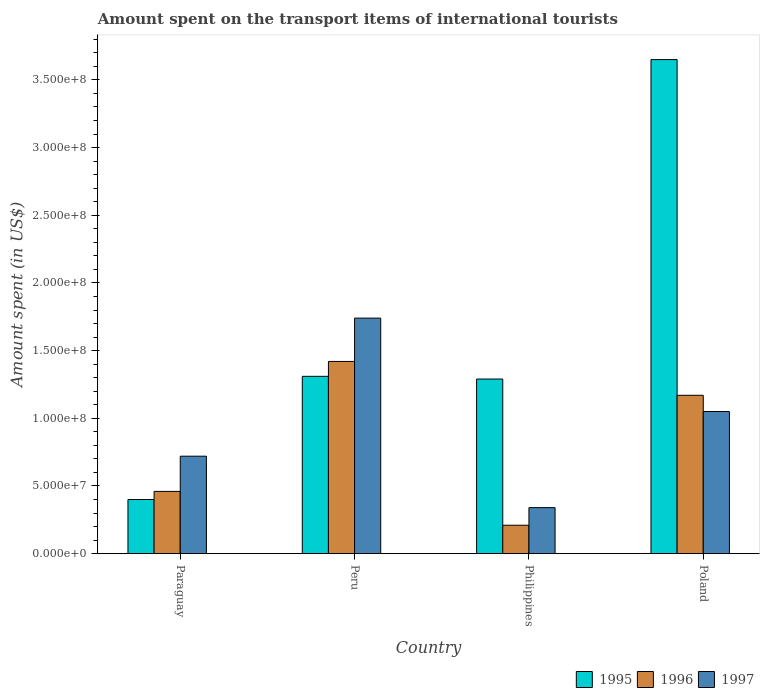How many groups of bars are there?
Offer a terse response. 4. Are the number of bars per tick equal to the number of legend labels?
Offer a terse response. Yes. Are the number of bars on each tick of the X-axis equal?
Your answer should be very brief. Yes. How many bars are there on the 1st tick from the left?
Provide a succinct answer. 3. How many bars are there on the 4th tick from the right?
Your answer should be compact. 3. What is the amount spent on the transport items of international tourists in 1995 in Poland?
Give a very brief answer. 3.65e+08. Across all countries, what is the maximum amount spent on the transport items of international tourists in 1997?
Offer a very short reply. 1.74e+08. Across all countries, what is the minimum amount spent on the transport items of international tourists in 1995?
Make the answer very short. 4.00e+07. What is the total amount spent on the transport items of international tourists in 1996 in the graph?
Ensure brevity in your answer.  3.26e+08. What is the difference between the amount spent on the transport items of international tourists in 1995 in Peru and that in Poland?
Give a very brief answer. -2.34e+08. What is the difference between the amount spent on the transport items of international tourists in 1997 in Poland and the amount spent on the transport items of international tourists in 1996 in Paraguay?
Make the answer very short. 5.90e+07. What is the average amount spent on the transport items of international tourists in 1995 per country?
Keep it short and to the point. 1.66e+08. What is the difference between the amount spent on the transport items of international tourists of/in 1997 and amount spent on the transport items of international tourists of/in 1995 in Poland?
Ensure brevity in your answer.  -2.60e+08. In how many countries, is the amount spent on the transport items of international tourists in 1996 greater than 50000000 US$?
Keep it short and to the point. 2. What is the ratio of the amount spent on the transport items of international tourists in 1996 in Paraguay to that in Peru?
Ensure brevity in your answer.  0.32. What is the difference between the highest and the second highest amount spent on the transport items of international tourists in 1995?
Your response must be concise. 2.36e+08. What is the difference between the highest and the lowest amount spent on the transport items of international tourists in 1995?
Offer a very short reply. 3.25e+08. In how many countries, is the amount spent on the transport items of international tourists in 1996 greater than the average amount spent on the transport items of international tourists in 1996 taken over all countries?
Ensure brevity in your answer.  2. Is the sum of the amount spent on the transport items of international tourists in 1997 in Paraguay and Philippines greater than the maximum amount spent on the transport items of international tourists in 1996 across all countries?
Provide a succinct answer. No. What does the 3rd bar from the left in Poland represents?
Provide a short and direct response. 1997. What does the 1st bar from the right in Peru represents?
Give a very brief answer. 1997. Is it the case that in every country, the sum of the amount spent on the transport items of international tourists in 1996 and amount spent on the transport items of international tourists in 1997 is greater than the amount spent on the transport items of international tourists in 1995?
Offer a very short reply. No. Are all the bars in the graph horizontal?
Make the answer very short. No. How many countries are there in the graph?
Your answer should be very brief. 4. What is the difference between two consecutive major ticks on the Y-axis?
Offer a very short reply. 5.00e+07. Does the graph contain any zero values?
Provide a succinct answer. No. Where does the legend appear in the graph?
Offer a terse response. Bottom right. How many legend labels are there?
Ensure brevity in your answer.  3. How are the legend labels stacked?
Ensure brevity in your answer.  Horizontal. What is the title of the graph?
Make the answer very short. Amount spent on the transport items of international tourists. Does "2012" appear as one of the legend labels in the graph?
Your response must be concise. No. What is the label or title of the X-axis?
Your response must be concise. Country. What is the label or title of the Y-axis?
Make the answer very short. Amount spent (in US$). What is the Amount spent (in US$) in 1995 in Paraguay?
Give a very brief answer. 4.00e+07. What is the Amount spent (in US$) in 1996 in Paraguay?
Your answer should be very brief. 4.60e+07. What is the Amount spent (in US$) in 1997 in Paraguay?
Provide a short and direct response. 7.20e+07. What is the Amount spent (in US$) in 1995 in Peru?
Provide a short and direct response. 1.31e+08. What is the Amount spent (in US$) in 1996 in Peru?
Your answer should be compact. 1.42e+08. What is the Amount spent (in US$) of 1997 in Peru?
Provide a short and direct response. 1.74e+08. What is the Amount spent (in US$) in 1995 in Philippines?
Your answer should be very brief. 1.29e+08. What is the Amount spent (in US$) of 1996 in Philippines?
Make the answer very short. 2.10e+07. What is the Amount spent (in US$) in 1997 in Philippines?
Ensure brevity in your answer.  3.40e+07. What is the Amount spent (in US$) of 1995 in Poland?
Offer a very short reply. 3.65e+08. What is the Amount spent (in US$) in 1996 in Poland?
Provide a short and direct response. 1.17e+08. What is the Amount spent (in US$) in 1997 in Poland?
Your response must be concise. 1.05e+08. Across all countries, what is the maximum Amount spent (in US$) in 1995?
Your answer should be very brief. 3.65e+08. Across all countries, what is the maximum Amount spent (in US$) in 1996?
Ensure brevity in your answer.  1.42e+08. Across all countries, what is the maximum Amount spent (in US$) in 1997?
Your response must be concise. 1.74e+08. Across all countries, what is the minimum Amount spent (in US$) in 1995?
Make the answer very short. 4.00e+07. Across all countries, what is the minimum Amount spent (in US$) in 1996?
Your answer should be compact. 2.10e+07. Across all countries, what is the minimum Amount spent (in US$) of 1997?
Provide a short and direct response. 3.40e+07. What is the total Amount spent (in US$) in 1995 in the graph?
Your answer should be compact. 6.65e+08. What is the total Amount spent (in US$) of 1996 in the graph?
Offer a terse response. 3.26e+08. What is the total Amount spent (in US$) of 1997 in the graph?
Provide a succinct answer. 3.85e+08. What is the difference between the Amount spent (in US$) in 1995 in Paraguay and that in Peru?
Provide a succinct answer. -9.10e+07. What is the difference between the Amount spent (in US$) of 1996 in Paraguay and that in Peru?
Keep it short and to the point. -9.60e+07. What is the difference between the Amount spent (in US$) in 1997 in Paraguay and that in Peru?
Your response must be concise. -1.02e+08. What is the difference between the Amount spent (in US$) of 1995 in Paraguay and that in Philippines?
Provide a succinct answer. -8.90e+07. What is the difference between the Amount spent (in US$) in 1996 in Paraguay and that in Philippines?
Offer a terse response. 2.50e+07. What is the difference between the Amount spent (in US$) of 1997 in Paraguay and that in Philippines?
Your answer should be compact. 3.80e+07. What is the difference between the Amount spent (in US$) in 1995 in Paraguay and that in Poland?
Give a very brief answer. -3.25e+08. What is the difference between the Amount spent (in US$) in 1996 in Paraguay and that in Poland?
Your response must be concise. -7.10e+07. What is the difference between the Amount spent (in US$) of 1997 in Paraguay and that in Poland?
Keep it short and to the point. -3.30e+07. What is the difference between the Amount spent (in US$) of 1996 in Peru and that in Philippines?
Offer a terse response. 1.21e+08. What is the difference between the Amount spent (in US$) in 1997 in Peru and that in Philippines?
Offer a terse response. 1.40e+08. What is the difference between the Amount spent (in US$) in 1995 in Peru and that in Poland?
Offer a very short reply. -2.34e+08. What is the difference between the Amount spent (in US$) of 1996 in Peru and that in Poland?
Your answer should be compact. 2.50e+07. What is the difference between the Amount spent (in US$) in 1997 in Peru and that in Poland?
Give a very brief answer. 6.90e+07. What is the difference between the Amount spent (in US$) of 1995 in Philippines and that in Poland?
Ensure brevity in your answer.  -2.36e+08. What is the difference between the Amount spent (in US$) of 1996 in Philippines and that in Poland?
Provide a short and direct response. -9.60e+07. What is the difference between the Amount spent (in US$) in 1997 in Philippines and that in Poland?
Your response must be concise. -7.10e+07. What is the difference between the Amount spent (in US$) in 1995 in Paraguay and the Amount spent (in US$) in 1996 in Peru?
Keep it short and to the point. -1.02e+08. What is the difference between the Amount spent (in US$) of 1995 in Paraguay and the Amount spent (in US$) of 1997 in Peru?
Provide a short and direct response. -1.34e+08. What is the difference between the Amount spent (in US$) in 1996 in Paraguay and the Amount spent (in US$) in 1997 in Peru?
Your response must be concise. -1.28e+08. What is the difference between the Amount spent (in US$) in 1995 in Paraguay and the Amount spent (in US$) in 1996 in Philippines?
Ensure brevity in your answer.  1.90e+07. What is the difference between the Amount spent (in US$) in 1995 in Paraguay and the Amount spent (in US$) in 1997 in Philippines?
Provide a short and direct response. 6.00e+06. What is the difference between the Amount spent (in US$) in 1995 in Paraguay and the Amount spent (in US$) in 1996 in Poland?
Provide a succinct answer. -7.70e+07. What is the difference between the Amount spent (in US$) in 1995 in Paraguay and the Amount spent (in US$) in 1997 in Poland?
Offer a very short reply. -6.50e+07. What is the difference between the Amount spent (in US$) in 1996 in Paraguay and the Amount spent (in US$) in 1997 in Poland?
Make the answer very short. -5.90e+07. What is the difference between the Amount spent (in US$) in 1995 in Peru and the Amount spent (in US$) in 1996 in Philippines?
Ensure brevity in your answer.  1.10e+08. What is the difference between the Amount spent (in US$) in 1995 in Peru and the Amount spent (in US$) in 1997 in Philippines?
Keep it short and to the point. 9.70e+07. What is the difference between the Amount spent (in US$) in 1996 in Peru and the Amount spent (in US$) in 1997 in Philippines?
Your response must be concise. 1.08e+08. What is the difference between the Amount spent (in US$) in 1995 in Peru and the Amount spent (in US$) in 1996 in Poland?
Provide a short and direct response. 1.40e+07. What is the difference between the Amount spent (in US$) of 1995 in Peru and the Amount spent (in US$) of 1997 in Poland?
Offer a very short reply. 2.60e+07. What is the difference between the Amount spent (in US$) of 1996 in Peru and the Amount spent (in US$) of 1997 in Poland?
Your answer should be very brief. 3.70e+07. What is the difference between the Amount spent (in US$) in 1995 in Philippines and the Amount spent (in US$) in 1996 in Poland?
Make the answer very short. 1.20e+07. What is the difference between the Amount spent (in US$) of 1995 in Philippines and the Amount spent (in US$) of 1997 in Poland?
Provide a succinct answer. 2.40e+07. What is the difference between the Amount spent (in US$) in 1996 in Philippines and the Amount spent (in US$) in 1997 in Poland?
Your answer should be very brief. -8.40e+07. What is the average Amount spent (in US$) in 1995 per country?
Ensure brevity in your answer.  1.66e+08. What is the average Amount spent (in US$) of 1996 per country?
Keep it short and to the point. 8.15e+07. What is the average Amount spent (in US$) in 1997 per country?
Provide a succinct answer. 9.62e+07. What is the difference between the Amount spent (in US$) of 1995 and Amount spent (in US$) of 1996 in Paraguay?
Keep it short and to the point. -6.00e+06. What is the difference between the Amount spent (in US$) in 1995 and Amount spent (in US$) in 1997 in Paraguay?
Give a very brief answer. -3.20e+07. What is the difference between the Amount spent (in US$) in 1996 and Amount spent (in US$) in 1997 in Paraguay?
Provide a succinct answer. -2.60e+07. What is the difference between the Amount spent (in US$) of 1995 and Amount spent (in US$) of 1996 in Peru?
Offer a very short reply. -1.10e+07. What is the difference between the Amount spent (in US$) of 1995 and Amount spent (in US$) of 1997 in Peru?
Keep it short and to the point. -4.30e+07. What is the difference between the Amount spent (in US$) in 1996 and Amount spent (in US$) in 1997 in Peru?
Your answer should be compact. -3.20e+07. What is the difference between the Amount spent (in US$) in 1995 and Amount spent (in US$) in 1996 in Philippines?
Offer a terse response. 1.08e+08. What is the difference between the Amount spent (in US$) of 1995 and Amount spent (in US$) of 1997 in Philippines?
Provide a succinct answer. 9.50e+07. What is the difference between the Amount spent (in US$) of 1996 and Amount spent (in US$) of 1997 in Philippines?
Provide a succinct answer. -1.30e+07. What is the difference between the Amount spent (in US$) of 1995 and Amount spent (in US$) of 1996 in Poland?
Provide a succinct answer. 2.48e+08. What is the difference between the Amount spent (in US$) of 1995 and Amount spent (in US$) of 1997 in Poland?
Keep it short and to the point. 2.60e+08. What is the ratio of the Amount spent (in US$) in 1995 in Paraguay to that in Peru?
Ensure brevity in your answer.  0.31. What is the ratio of the Amount spent (in US$) of 1996 in Paraguay to that in Peru?
Your response must be concise. 0.32. What is the ratio of the Amount spent (in US$) in 1997 in Paraguay to that in Peru?
Your answer should be compact. 0.41. What is the ratio of the Amount spent (in US$) in 1995 in Paraguay to that in Philippines?
Provide a succinct answer. 0.31. What is the ratio of the Amount spent (in US$) in 1996 in Paraguay to that in Philippines?
Make the answer very short. 2.19. What is the ratio of the Amount spent (in US$) in 1997 in Paraguay to that in Philippines?
Give a very brief answer. 2.12. What is the ratio of the Amount spent (in US$) in 1995 in Paraguay to that in Poland?
Ensure brevity in your answer.  0.11. What is the ratio of the Amount spent (in US$) of 1996 in Paraguay to that in Poland?
Provide a succinct answer. 0.39. What is the ratio of the Amount spent (in US$) of 1997 in Paraguay to that in Poland?
Your answer should be compact. 0.69. What is the ratio of the Amount spent (in US$) in 1995 in Peru to that in Philippines?
Provide a short and direct response. 1.02. What is the ratio of the Amount spent (in US$) in 1996 in Peru to that in Philippines?
Give a very brief answer. 6.76. What is the ratio of the Amount spent (in US$) of 1997 in Peru to that in Philippines?
Your response must be concise. 5.12. What is the ratio of the Amount spent (in US$) of 1995 in Peru to that in Poland?
Ensure brevity in your answer.  0.36. What is the ratio of the Amount spent (in US$) in 1996 in Peru to that in Poland?
Provide a short and direct response. 1.21. What is the ratio of the Amount spent (in US$) of 1997 in Peru to that in Poland?
Provide a short and direct response. 1.66. What is the ratio of the Amount spent (in US$) of 1995 in Philippines to that in Poland?
Give a very brief answer. 0.35. What is the ratio of the Amount spent (in US$) in 1996 in Philippines to that in Poland?
Ensure brevity in your answer.  0.18. What is the ratio of the Amount spent (in US$) in 1997 in Philippines to that in Poland?
Keep it short and to the point. 0.32. What is the difference between the highest and the second highest Amount spent (in US$) in 1995?
Offer a very short reply. 2.34e+08. What is the difference between the highest and the second highest Amount spent (in US$) of 1996?
Make the answer very short. 2.50e+07. What is the difference between the highest and the second highest Amount spent (in US$) in 1997?
Provide a succinct answer. 6.90e+07. What is the difference between the highest and the lowest Amount spent (in US$) of 1995?
Offer a terse response. 3.25e+08. What is the difference between the highest and the lowest Amount spent (in US$) in 1996?
Give a very brief answer. 1.21e+08. What is the difference between the highest and the lowest Amount spent (in US$) of 1997?
Offer a very short reply. 1.40e+08. 